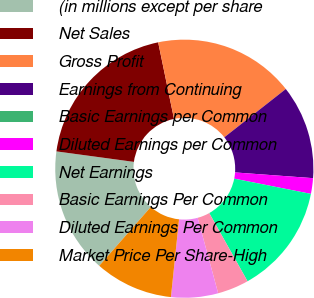Convert chart. <chart><loc_0><loc_0><loc_500><loc_500><pie_chart><fcel>(in millions except per share<fcel>Net Sales<fcel>Gross Profit<fcel>Earnings from Continuing<fcel>Basic Earnings per Common<fcel>Diluted Earnings per Common<fcel>Net Earnings<fcel>Basic Earnings Per Common<fcel>Diluted Earnings Per Common<fcel>Market Price Per Share-High<nl><fcel>15.69%<fcel>19.61%<fcel>17.65%<fcel>11.76%<fcel>0.0%<fcel>1.96%<fcel>13.73%<fcel>3.92%<fcel>5.88%<fcel>9.8%<nl></chart> 